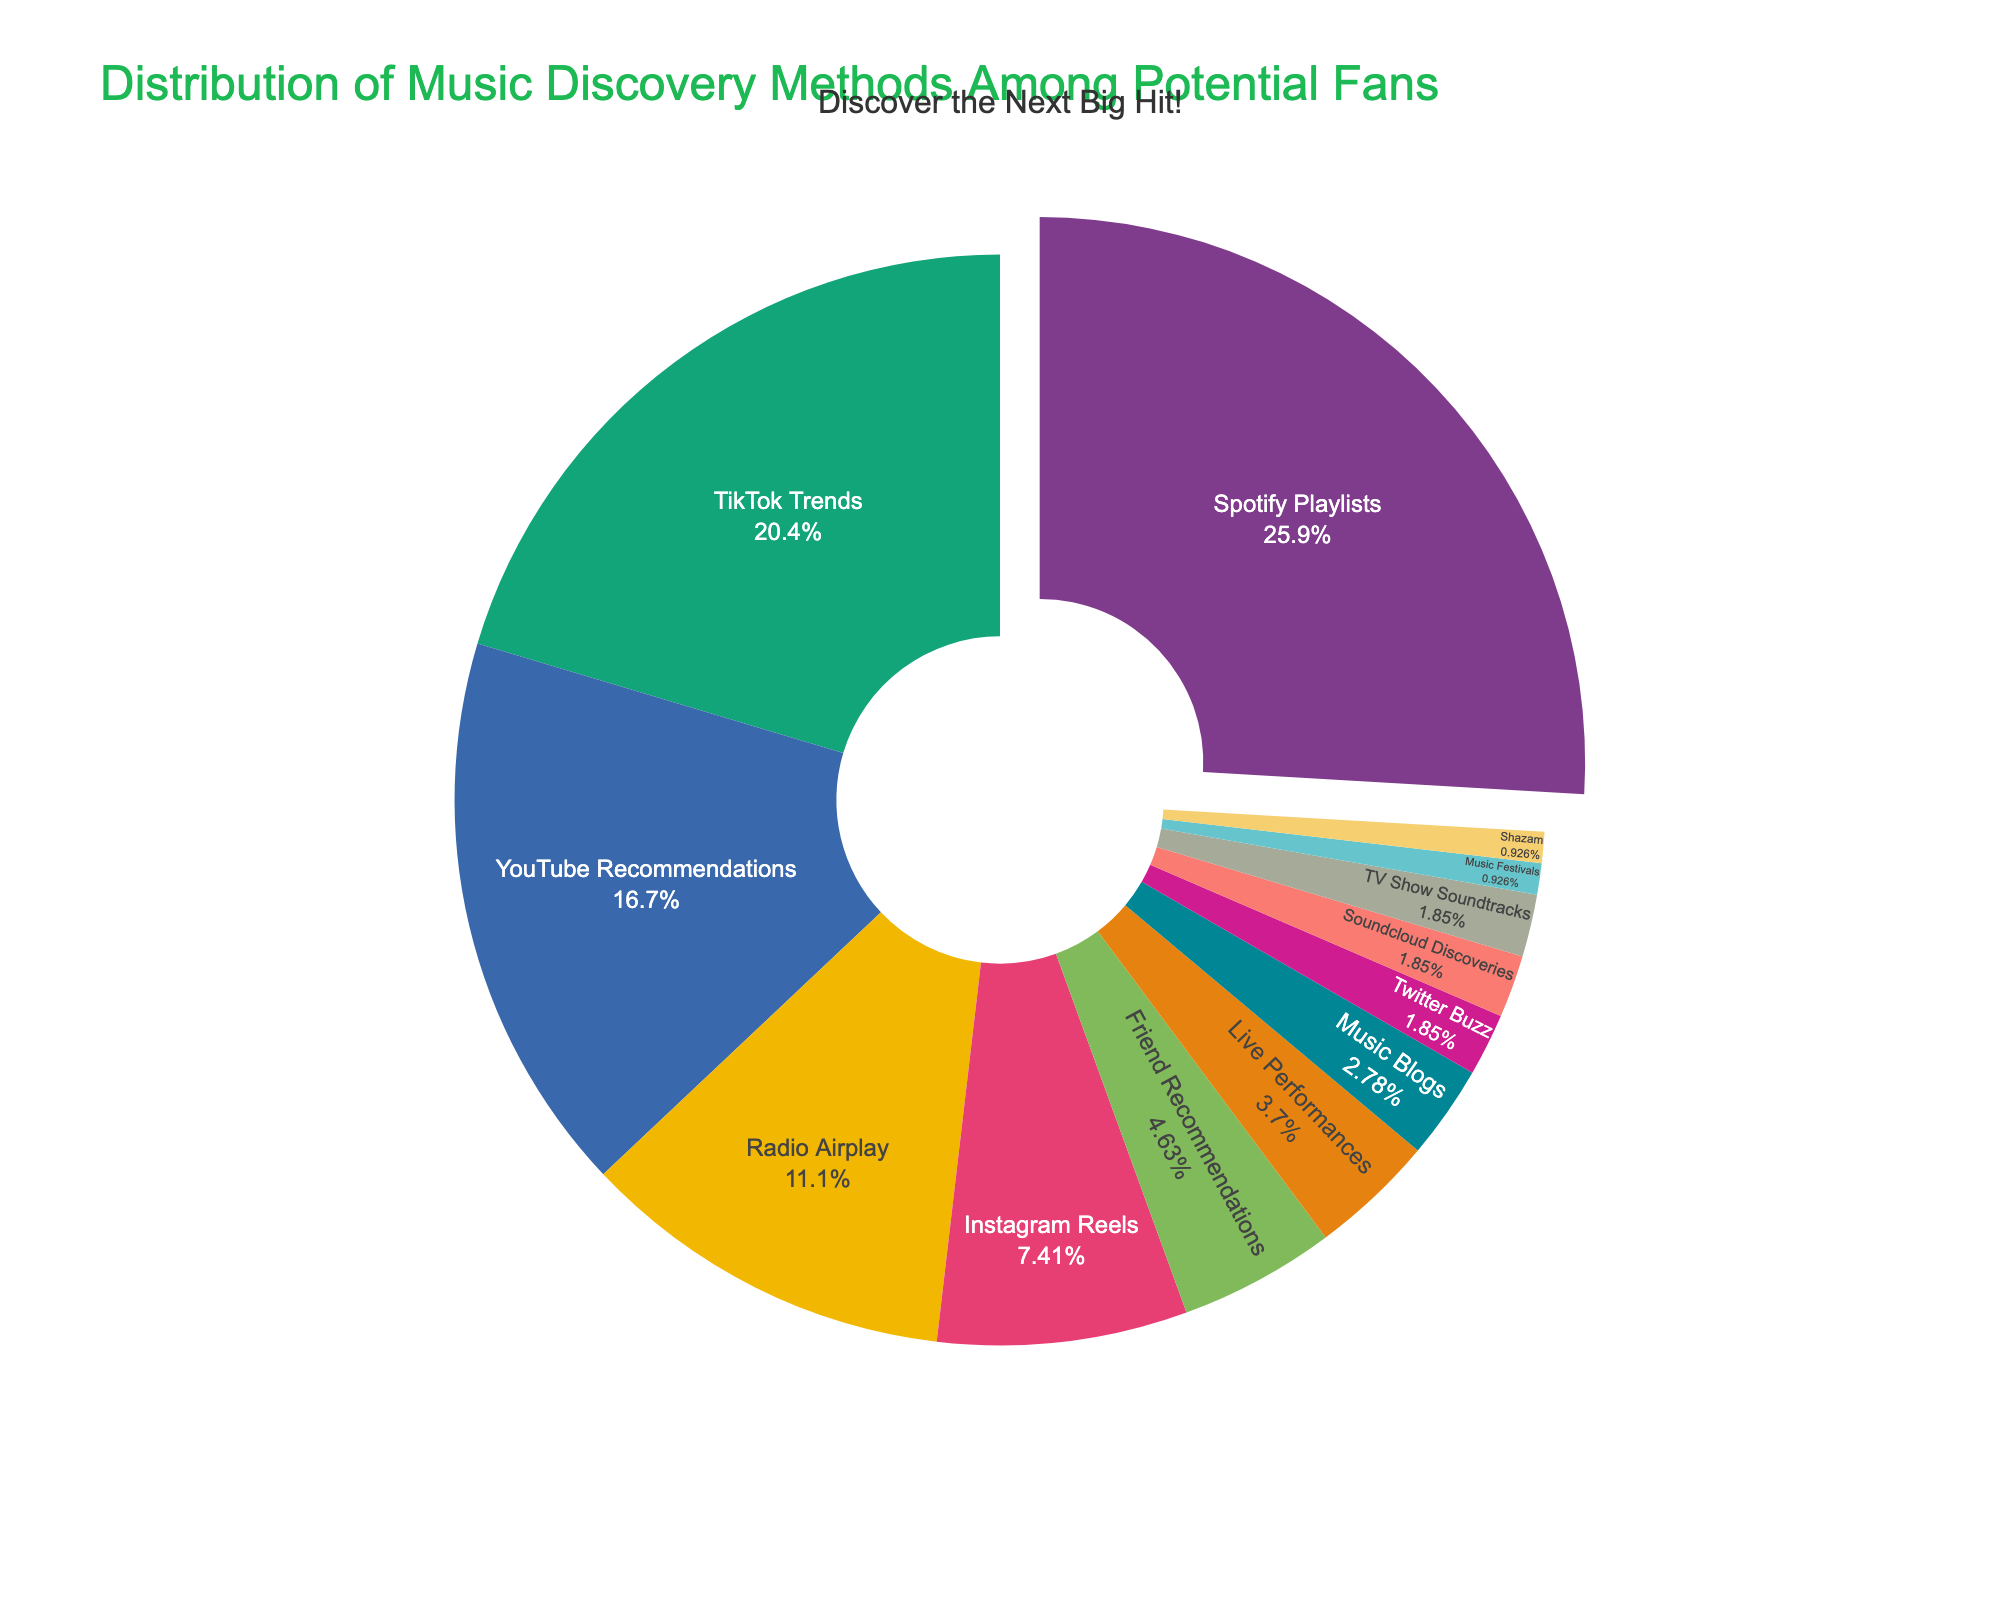What's the most popular music discovery method according to the pie chart? The pie chart shows different music discovery methods with their respective percentages. The segment with the highest percentage represents the most popular method. In this case, it is "Spotify Playlists" with 28%.
Answer: Spotify Playlists What is the combined percentage of TikTok Trends and YouTube Recommendations? To find the combined percentage, add the percentages for TikTok Trends (22%) and YouTube Recommendations (18%). 22% + 18% = 40%.
Answer: 40% How much higher is Spotify Playlists compared to the second-highest discovery method? First, identify the percentages for Spotify Playlists (28%) and the second-highest, TikTok Trends (22%). Subtract 22% from 28% to find the difference. 28% - 22% = 6%.
Answer: 6% Which two methods have the smallest shares, and what is their combined percentage? The smallest segments in the pie chart represent Shazam, Music Festivals, TV Show Soundtracks, Soundcloud Discoveries, and Twitter Buzz, all with 1% or 2%. The smallest two are Music Festivals and Shazam, each with 1%. Their combined percentage is 1% + 1% = 2%.
Answer: Music Festivals and Shazam, 2% What is the difference in percentage between Radio Airplay and Instagram Reels? Identify their percentages from the chart: Radio Airplay (12%) and Instagram Reels (8%). Subtract the percentage of Instagram Reels from Radio Airplay. 12% - 8% = 4%.
Answer: 4% What is the total percentage for all music discovery methods less than 5%? Identify all methods with less than 5%: Friend Recommendations (5%), Live Performances (4%), Music Blogs (3%), Twitter Buzz (2%), Soundcloud Discoveries (2%), TV Show Soundtracks (2%), Music Festivals (1%), and Shazam (1%). Add these values together: 5% + 4% + 3% + 2% + 2% + 2% + 1% + 1% = 20%.
Answer: 20% Which discovery method is represented by the color used for the second-largest segment? The second-largest segment in the pie chart is TikTok Trends with 22%. The color used for this segment on the pie chart represents TikTok Trends. Identify the color visually from the chart.
Answer: TikTok Trends How does the percentage of YouTube Recommendations compare to that of Instagram Reels? Compare the percentages of YouTube Recommendations (18%) and Instagram Reels (8%). Since 18% is greater than 8%, YouTube Recommendations has a higher percentage.
Answer: YouTube Recommendations is higher If Friend Recommendations and Live Performances were combined, what would their new ranking be in terms of percentage share? Combine Friend Recommendations (5%) and Live Performances (4%) to get 5% + 4% = 9%. The combined percentage (9%) would be higher than Instagram Reels (8%) but lower than Radio Airplay (12%), placing it in the fifth position.
Answer: Fifth What's the sum of the percentages for the discovery methods represented by three largest segments? Identify the three largest segments and their percentages: Spotify Playlists (28%), TikTok Trends (22%), and YouTube Recommendations (18%). Add these percentages together: 28% + 22% + 18% = 68%.
Answer: 68% 